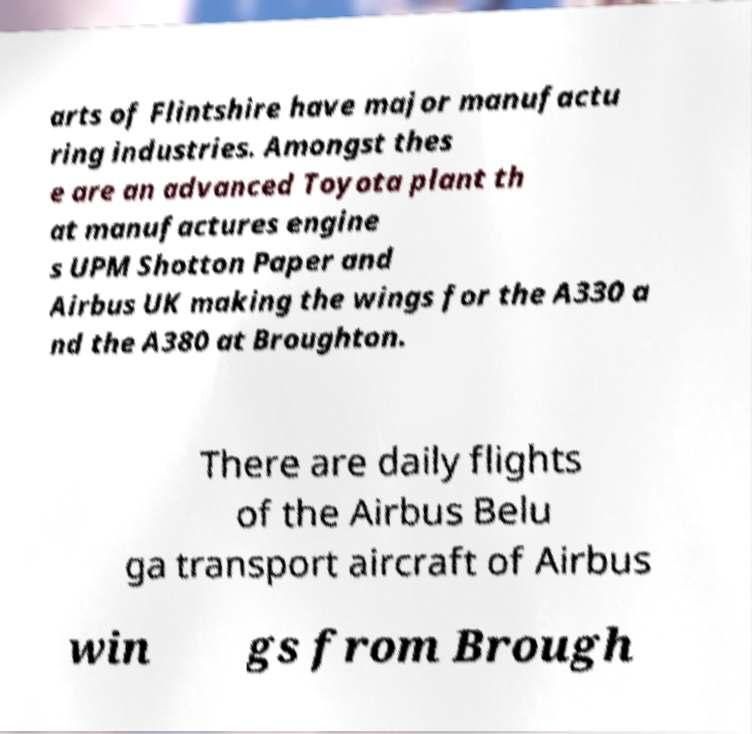There's text embedded in this image that I need extracted. Can you transcribe it verbatim? arts of Flintshire have major manufactu ring industries. Amongst thes e are an advanced Toyota plant th at manufactures engine s UPM Shotton Paper and Airbus UK making the wings for the A330 a nd the A380 at Broughton. There are daily flights of the Airbus Belu ga transport aircraft of Airbus win gs from Brough 